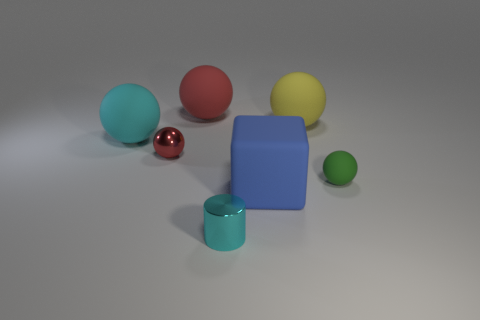Can you tell me what colors are present in the image? Certainly! The image displays objects in blue, green, red, yellow, and what appears to be a chrome or metallic color. 